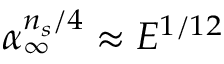Convert formula to latex. <formula><loc_0><loc_0><loc_500><loc_500>\alpha _ { \infty } ^ { n _ { s } / 4 } \approx E ^ { 1 / 1 2 }</formula> 